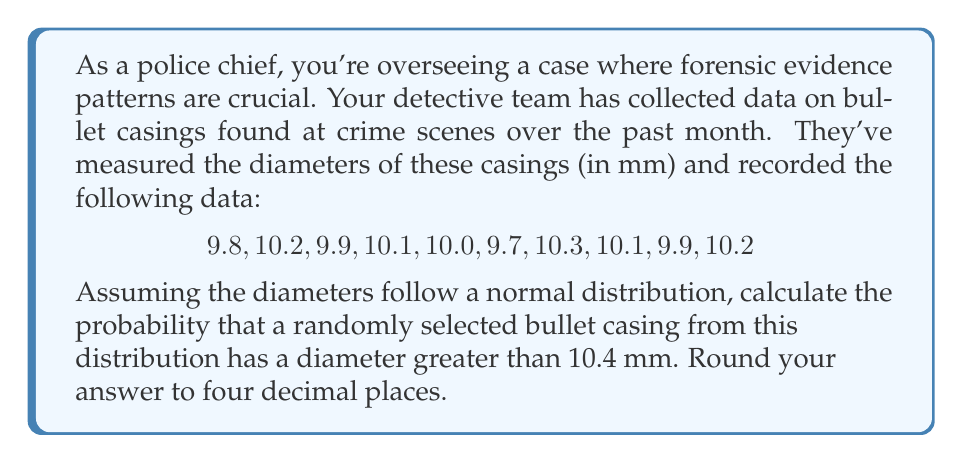Could you help me with this problem? To solve this problem, we'll follow these steps:

1. Calculate the mean ($\mu$) of the sample:
   $$\mu = \frac{9.8 + 10.2 + 9.9 + 10.1 + 10.0 + 9.7 + 10.3 + 10.1 + 9.9 + 10.2}{10} = 10.02$$

2. Calculate the standard deviation ($\sigma$) of the sample:
   $$\sigma = \sqrt{\frac{\sum(x_i - \mu)^2}{n-1}}$$
   $$\sigma = \sqrt{\frac{(9.8-10.02)^2 + (10.2-10.02)^2 + ... + (10.2-10.02)^2}{9}} \approx 0.1989$$

3. Standardize the value 10.4 to get the z-score:
   $$z = \frac{x - \mu}{\sigma} = \frac{10.4 - 10.02}{0.1989} \approx 1.9106$$

4. Find the probability using the standard normal distribution table or a calculator:
   P(X > 10.4) = P(Z > 1.9106) ≈ 0.0280

5. Round the result to four decimal places: 0.0280

This probability represents the likelihood that a randomly selected bullet casing from this distribution has a diameter greater than 10.4 mm.
Answer: 0.0280 